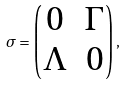Convert formula to latex. <formula><loc_0><loc_0><loc_500><loc_500>\sigma = \begin{pmatrix} 0 & \Gamma \\ \Lambda & 0 \end{pmatrix} ,</formula> 